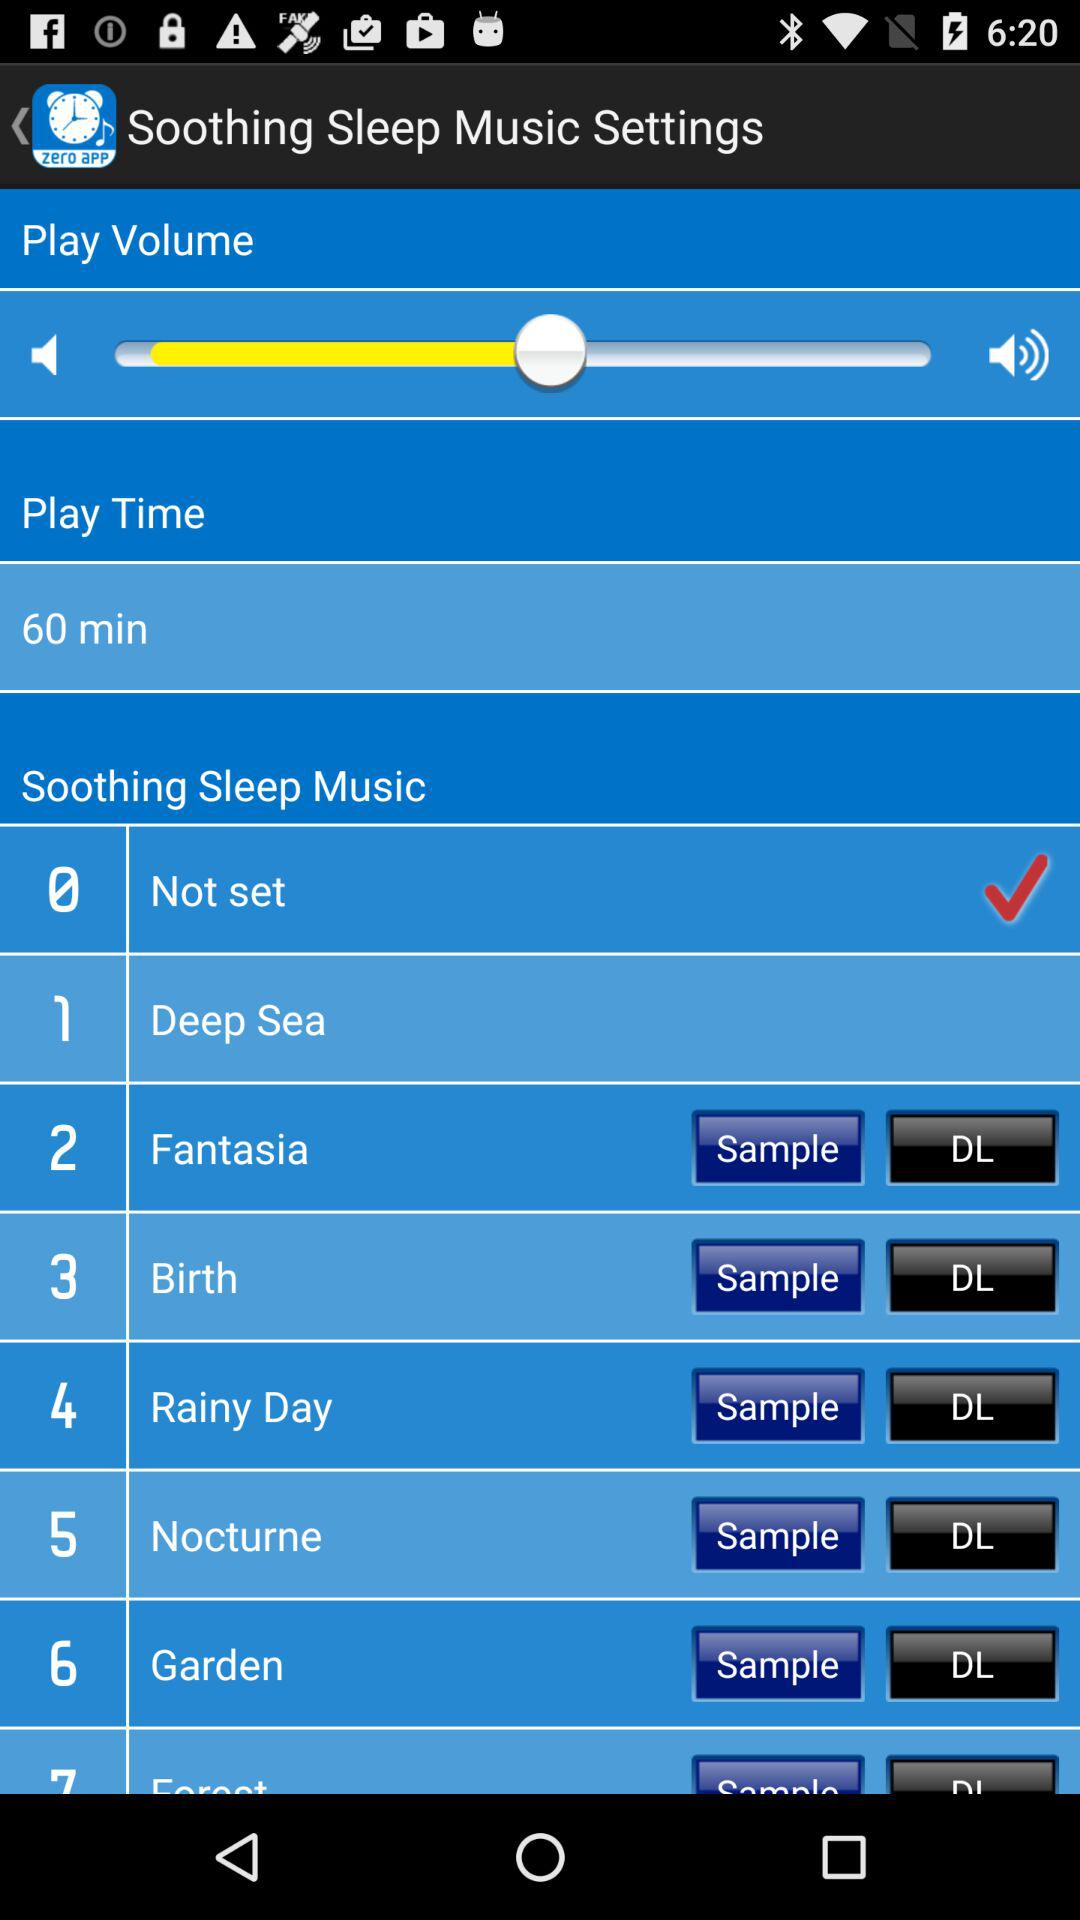What is "Play Time"? The play time is 60 minutes. 